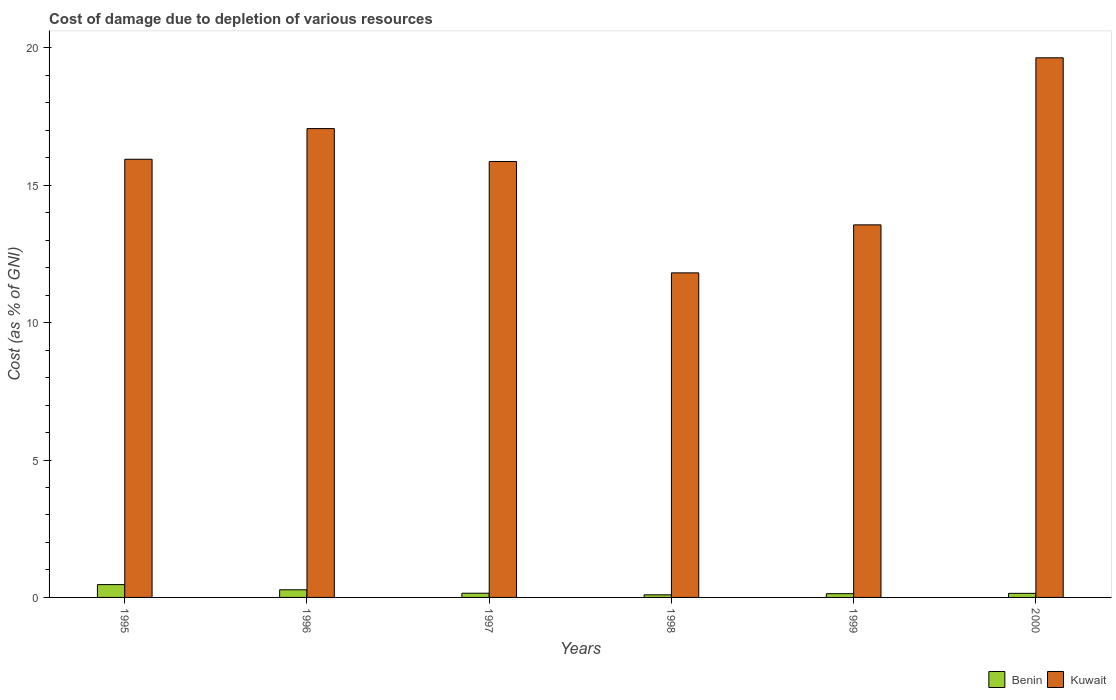How many different coloured bars are there?
Provide a succinct answer. 2. Are the number of bars per tick equal to the number of legend labels?
Offer a very short reply. Yes. What is the label of the 1st group of bars from the left?
Offer a very short reply. 1995. In how many cases, is the number of bars for a given year not equal to the number of legend labels?
Your response must be concise. 0. What is the cost of damage caused due to the depletion of various resources in Kuwait in 1996?
Your response must be concise. 17.06. Across all years, what is the maximum cost of damage caused due to the depletion of various resources in Benin?
Provide a short and direct response. 0.47. Across all years, what is the minimum cost of damage caused due to the depletion of various resources in Kuwait?
Offer a terse response. 11.81. In which year was the cost of damage caused due to the depletion of various resources in Kuwait minimum?
Make the answer very short. 1998. What is the total cost of damage caused due to the depletion of various resources in Kuwait in the graph?
Offer a terse response. 93.87. What is the difference between the cost of damage caused due to the depletion of various resources in Kuwait in 1998 and that in 1999?
Keep it short and to the point. -1.75. What is the difference between the cost of damage caused due to the depletion of various resources in Kuwait in 1998 and the cost of damage caused due to the depletion of various resources in Benin in 1996?
Give a very brief answer. 11.53. What is the average cost of damage caused due to the depletion of various resources in Benin per year?
Give a very brief answer. 0.21. In the year 1998, what is the difference between the cost of damage caused due to the depletion of various resources in Benin and cost of damage caused due to the depletion of various resources in Kuwait?
Ensure brevity in your answer.  -11.71. What is the ratio of the cost of damage caused due to the depletion of various resources in Benin in 1998 to that in 2000?
Your answer should be very brief. 0.64. Is the cost of damage caused due to the depletion of various resources in Kuwait in 1995 less than that in 1996?
Offer a terse response. Yes. What is the difference between the highest and the second highest cost of damage caused due to the depletion of various resources in Benin?
Provide a short and direct response. 0.19. What is the difference between the highest and the lowest cost of damage caused due to the depletion of various resources in Benin?
Give a very brief answer. 0.37. Is the sum of the cost of damage caused due to the depletion of various resources in Benin in 1995 and 1998 greater than the maximum cost of damage caused due to the depletion of various resources in Kuwait across all years?
Keep it short and to the point. No. What does the 1st bar from the left in 1998 represents?
Keep it short and to the point. Benin. What does the 2nd bar from the right in 1995 represents?
Your response must be concise. Benin. Are all the bars in the graph horizontal?
Ensure brevity in your answer.  No. How many years are there in the graph?
Your answer should be very brief. 6. What is the difference between two consecutive major ticks on the Y-axis?
Offer a very short reply. 5. Does the graph contain any zero values?
Your answer should be compact. No. Where does the legend appear in the graph?
Provide a succinct answer. Bottom right. What is the title of the graph?
Give a very brief answer. Cost of damage due to depletion of various resources. What is the label or title of the X-axis?
Keep it short and to the point. Years. What is the label or title of the Y-axis?
Provide a short and direct response. Cost (as % of GNI). What is the Cost (as % of GNI) in Benin in 1995?
Your answer should be very brief. 0.47. What is the Cost (as % of GNI) in Kuwait in 1995?
Your answer should be compact. 15.94. What is the Cost (as % of GNI) in Benin in 1996?
Your response must be concise. 0.28. What is the Cost (as % of GNI) of Kuwait in 1996?
Provide a succinct answer. 17.06. What is the Cost (as % of GNI) in Benin in 1997?
Your answer should be compact. 0.15. What is the Cost (as % of GNI) in Kuwait in 1997?
Your response must be concise. 15.86. What is the Cost (as % of GNI) in Benin in 1998?
Your answer should be very brief. 0.09. What is the Cost (as % of GNI) in Kuwait in 1998?
Make the answer very short. 11.81. What is the Cost (as % of GNI) of Benin in 1999?
Offer a very short reply. 0.14. What is the Cost (as % of GNI) in Kuwait in 1999?
Offer a very short reply. 13.56. What is the Cost (as % of GNI) of Benin in 2000?
Provide a succinct answer. 0.15. What is the Cost (as % of GNI) of Kuwait in 2000?
Offer a terse response. 19.64. Across all years, what is the maximum Cost (as % of GNI) in Benin?
Keep it short and to the point. 0.47. Across all years, what is the maximum Cost (as % of GNI) in Kuwait?
Make the answer very short. 19.64. Across all years, what is the minimum Cost (as % of GNI) of Benin?
Your answer should be very brief. 0.09. Across all years, what is the minimum Cost (as % of GNI) in Kuwait?
Provide a succinct answer. 11.81. What is the total Cost (as % of GNI) in Benin in the graph?
Give a very brief answer. 1.28. What is the total Cost (as % of GNI) of Kuwait in the graph?
Ensure brevity in your answer.  93.87. What is the difference between the Cost (as % of GNI) in Benin in 1995 and that in 1996?
Your response must be concise. 0.19. What is the difference between the Cost (as % of GNI) in Kuwait in 1995 and that in 1996?
Make the answer very short. -1.12. What is the difference between the Cost (as % of GNI) in Benin in 1995 and that in 1997?
Offer a very short reply. 0.31. What is the difference between the Cost (as % of GNI) of Kuwait in 1995 and that in 1997?
Ensure brevity in your answer.  0.08. What is the difference between the Cost (as % of GNI) of Benin in 1995 and that in 1998?
Ensure brevity in your answer.  0.37. What is the difference between the Cost (as % of GNI) of Kuwait in 1995 and that in 1998?
Offer a terse response. 4.13. What is the difference between the Cost (as % of GNI) of Benin in 1995 and that in 1999?
Your response must be concise. 0.33. What is the difference between the Cost (as % of GNI) of Kuwait in 1995 and that in 1999?
Offer a very short reply. 2.39. What is the difference between the Cost (as % of GNI) in Benin in 1995 and that in 2000?
Your answer should be compact. 0.32. What is the difference between the Cost (as % of GNI) in Kuwait in 1995 and that in 2000?
Ensure brevity in your answer.  -3.69. What is the difference between the Cost (as % of GNI) in Benin in 1996 and that in 1997?
Offer a very short reply. 0.13. What is the difference between the Cost (as % of GNI) in Kuwait in 1996 and that in 1997?
Make the answer very short. 1.2. What is the difference between the Cost (as % of GNI) of Benin in 1996 and that in 1998?
Provide a short and direct response. 0.18. What is the difference between the Cost (as % of GNI) in Kuwait in 1996 and that in 1998?
Offer a terse response. 5.25. What is the difference between the Cost (as % of GNI) of Benin in 1996 and that in 1999?
Offer a very short reply. 0.14. What is the difference between the Cost (as % of GNI) of Kuwait in 1996 and that in 1999?
Offer a terse response. 3.5. What is the difference between the Cost (as % of GNI) of Benin in 1996 and that in 2000?
Give a very brief answer. 0.13. What is the difference between the Cost (as % of GNI) in Kuwait in 1996 and that in 2000?
Ensure brevity in your answer.  -2.58. What is the difference between the Cost (as % of GNI) in Benin in 1997 and that in 1998?
Ensure brevity in your answer.  0.06. What is the difference between the Cost (as % of GNI) in Kuwait in 1997 and that in 1998?
Keep it short and to the point. 4.05. What is the difference between the Cost (as % of GNI) in Benin in 1997 and that in 1999?
Provide a succinct answer. 0.02. What is the difference between the Cost (as % of GNI) of Kuwait in 1997 and that in 1999?
Give a very brief answer. 2.31. What is the difference between the Cost (as % of GNI) in Benin in 1997 and that in 2000?
Your response must be concise. 0. What is the difference between the Cost (as % of GNI) in Kuwait in 1997 and that in 2000?
Provide a short and direct response. -3.77. What is the difference between the Cost (as % of GNI) in Benin in 1998 and that in 1999?
Your answer should be compact. -0.04. What is the difference between the Cost (as % of GNI) of Kuwait in 1998 and that in 1999?
Your answer should be very brief. -1.75. What is the difference between the Cost (as % of GNI) in Benin in 1998 and that in 2000?
Keep it short and to the point. -0.05. What is the difference between the Cost (as % of GNI) in Kuwait in 1998 and that in 2000?
Keep it short and to the point. -7.83. What is the difference between the Cost (as % of GNI) in Benin in 1999 and that in 2000?
Keep it short and to the point. -0.01. What is the difference between the Cost (as % of GNI) in Kuwait in 1999 and that in 2000?
Your answer should be compact. -6.08. What is the difference between the Cost (as % of GNI) in Benin in 1995 and the Cost (as % of GNI) in Kuwait in 1996?
Keep it short and to the point. -16.59. What is the difference between the Cost (as % of GNI) of Benin in 1995 and the Cost (as % of GNI) of Kuwait in 1997?
Your answer should be compact. -15.4. What is the difference between the Cost (as % of GNI) in Benin in 1995 and the Cost (as % of GNI) in Kuwait in 1998?
Give a very brief answer. -11.34. What is the difference between the Cost (as % of GNI) of Benin in 1995 and the Cost (as % of GNI) of Kuwait in 1999?
Make the answer very short. -13.09. What is the difference between the Cost (as % of GNI) in Benin in 1995 and the Cost (as % of GNI) in Kuwait in 2000?
Offer a terse response. -19.17. What is the difference between the Cost (as % of GNI) of Benin in 1996 and the Cost (as % of GNI) of Kuwait in 1997?
Your answer should be very brief. -15.58. What is the difference between the Cost (as % of GNI) of Benin in 1996 and the Cost (as % of GNI) of Kuwait in 1998?
Your answer should be very brief. -11.53. What is the difference between the Cost (as % of GNI) of Benin in 1996 and the Cost (as % of GNI) of Kuwait in 1999?
Keep it short and to the point. -13.28. What is the difference between the Cost (as % of GNI) of Benin in 1996 and the Cost (as % of GNI) of Kuwait in 2000?
Offer a very short reply. -19.36. What is the difference between the Cost (as % of GNI) in Benin in 1997 and the Cost (as % of GNI) in Kuwait in 1998?
Give a very brief answer. -11.66. What is the difference between the Cost (as % of GNI) in Benin in 1997 and the Cost (as % of GNI) in Kuwait in 1999?
Give a very brief answer. -13.4. What is the difference between the Cost (as % of GNI) of Benin in 1997 and the Cost (as % of GNI) of Kuwait in 2000?
Provide a succinct answer. -19.48. What is the difference between the Cost (as % of GNI) of Benin in 1998 and the Cost (as % of GNI) of Kuwait in 1999?
Your answer should be compact. -13.46. What is the difference between the Cost (as % of GNI) in Benin in 1998 and the Cost (as % of GNI) in Kuwait in 2000?
Offer a terse response. -19.54. What is the difference between the Cost (as % of GNI) in Benin in 1999 and the Cost (as % of GNI) in Kuwait in 2000?
Provide a succinct answer. -19.5. What is the average Cost (as % of GNI) in Benin per year?
Make the answer very short. 0.21. What is the average Cost (as % of GNI) of Kuwait per year?
Your answer should be very brief. 15.64. In the year 1995, what is the difference between the Cost (as % of GNI) in Benin and Cost (as % of GNI) in Kuwait?
Your response must be concise. -15.48. In the year 1996, what is the difference between the Cost (as % of GNI) of Benin and Cost (as % of GNI) of Kuwait?
Provide a short and direct response. -16.78. In the year 1997, what is the difference between the Cost (as % of GNI) of Benin and Cost (as % of GNI) of Kuwait?
Keep it short and to the point. -15.71. In the year 1998, what is the difference between the Cost (as % of GNI) in Benin and Cost (as % of GNI) in Kuwait?
Provide a short and direct response. -11.71. In the year 1999, what is the difference between the Cost (as % of GNI) in Benin and Cost (as % of GNI) in Kuwait?
Give a very brief answer. -13.42. In the year 2000, what is the difference between the Cost (as % of GNI) in Benin and Cost (as % of GNI) in Kuwait?
Keep it short and to the point. -19.49. What is the ratio of the Cost (as % of GNI) of Benin in 1995 to that in 1996?
Ensure brevity in your answer.  1.68. What is the ratio of the Cost (as % of GNI) in Kuwait in 1995 to that in 1996?
Your response must be concise. 0.93. What is the ratio of the Cost (as % of GNI) in Benin in 1995 to that in 1997?
Make the answer very short. 3.06. What is the ratio of the Cost (as % of GNI) in Benin in 1995 to that in 1998?
Your answer should be very brief. 4.92. What is the ratio of the Cost (as % of GNI) of Kuwait in 1995 to that in 1998?
Your answer should be very brief. 1.35. What is the ratio of the Cost (as % of GNI) of Benin in 1995 to that in 1999?
Your response must be concise. 3.43. What is the ratio of the Cost (as % of GNI) of Kuwait in 1995 to that in 1999?
Your response must be concise. 1.18. What is the ratio of the Cost (as % of GNI) in Benin in 1995 to that in 2000?
Offer a terse response. 3.15. What is the ratio of the Cost (as % of GNI) in Kuwait in 1995 to that in 2000?
Ensure brevity in your answer.  0.81. What is the ratio of the Cost (as % of GNI) in Benin in 1996 to that in 1997?
Provide a short and direct response. 1.82. What is the ratio of the Cost (as % of GNI) of Kuwait in 1996 to that in 1997?
Provide a short and direct response. 1.08. What is the ratio of the Cost (as % of GNI) of Benin in 1996 to that in 1998?
Offer a very short reply. 2.94. What is the ratio of the Cost (as % of GNI) in Kuwait in 1996 to that in 1998?
Offer a very short reply. 1.44. What is the ratio of the Cost (as % of GNI) of Benin in 1996 to that in 1999?
Ensure brevity in your answer.  2.05. What is the ratio of the Cost (as % of GNI) of Kuwait in 1996 to that in 1999?
Your response must be concise. 1.26. What is the ratio of the Cost (as % of GNI) of Benin in 1996 to that in 2000?
Your answer should be very brief. 1.88. What is the ratio of the Cost (as % of GNI) in Kuwait in 1996 to that in 2000?
Your response must be concise. 0.87. What is the ratio of the Cost (as % of GNI) in Benin in 1997 to that in 1998?
Provide a short and direct response. 1.61. What is the ratio of the Cost (as % of GNI) in Kuwait in 1997 to that in 1998?
Ensure brevity in your answer.  1.34. What is the ratio of the Cost (as % of GNI) in Benin in 1997 to that in 1999?
Provide a short and direct response. 1.12. What is the ratio of the Cost (as % of GNI) in Kuwait in 1997 to that in 1999?
Provide a short and direct response. 1.17. What is the ratio of the Cost (as % of GNI) in Benin in 1997 to that in 2000?
Ensure brevity in your answer.  1.03. What is the ratio of the Cost (as % of GNI) of Kuwait in 1997 to that in 2000?
Give a very brief answer. 0.81. What is the ratio of the Cost (as % of GNI) of Benin in 1998 to that in 1999?
Your answer should be compact. 0.7. What is the ratio of the Cost (as % of GNI) in Kuwait in 1998 to that in 1999?
Keep it short and to the point. 0.87. What is the ratio of the Cost (as % of GNI) of Benin in 1998 to that in 2000?
Provide a short and direct response. 0.64. What is the ratio of the Cost (as % of GNI) in Kuwait in 1998 to that in 2000?
Offer a terse response. 0.6. What is the ratio of the Cost (as % of GNI) in Benin in 1999 to that in 2000?
Ensure brevity in your answer.  0.92. What is the ratio of the Cost (as % of GNI) in Kuwait in 1999 to that in 2000?
Offer a very short reply. 0.69. What is the difference between the highest and the second highest Cost (as % of GNI) in Benin?
Offer a terse response. 0.19. What is the difference between the highest and the second highest Cost (as % of GNI) in Kuwait?
Offer a very short reply. 2.58. What is the difference between the highest and the lowest Cost (as % of GNI) of Benin?
Provide a succinct answer. 0.37. What is the difference between the highest and the lowest Cost (as % of GNI) in Kuwait?
Make the answer very short. 7.83. 